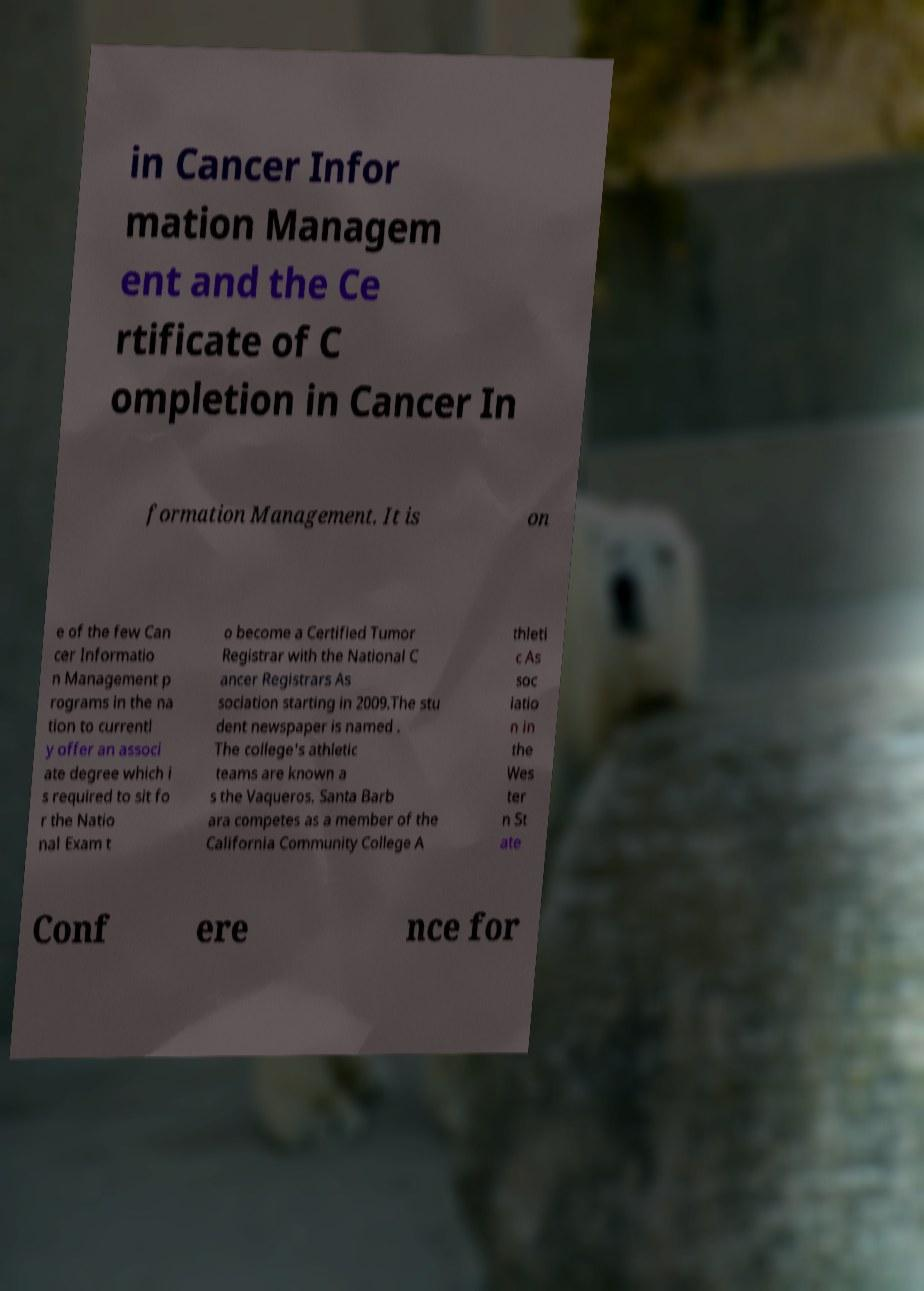Could you assist in decoding the text presented in this image and type it out clearly? in Cancer Infor mation Managem ent and the Ce rtificate of C ompletion in Cancer In formation Management. It is on e of the few Can cer Informatio n Management p rograms in the na tion to currentl y offer an associ ate degree which i s required to sit fo r the Natio nal Exam t o become a Certified Tumor Registrar with the National C ancer Registrars As sociation starting in 2009.The stu dent newspaper is named . The college's athletic teams are known a s the Vaqueros. Santa Barb ara competes as a member of the California Community College A thleti c As soc iatio n in the Wes ter n St ate Conf ere nce for 